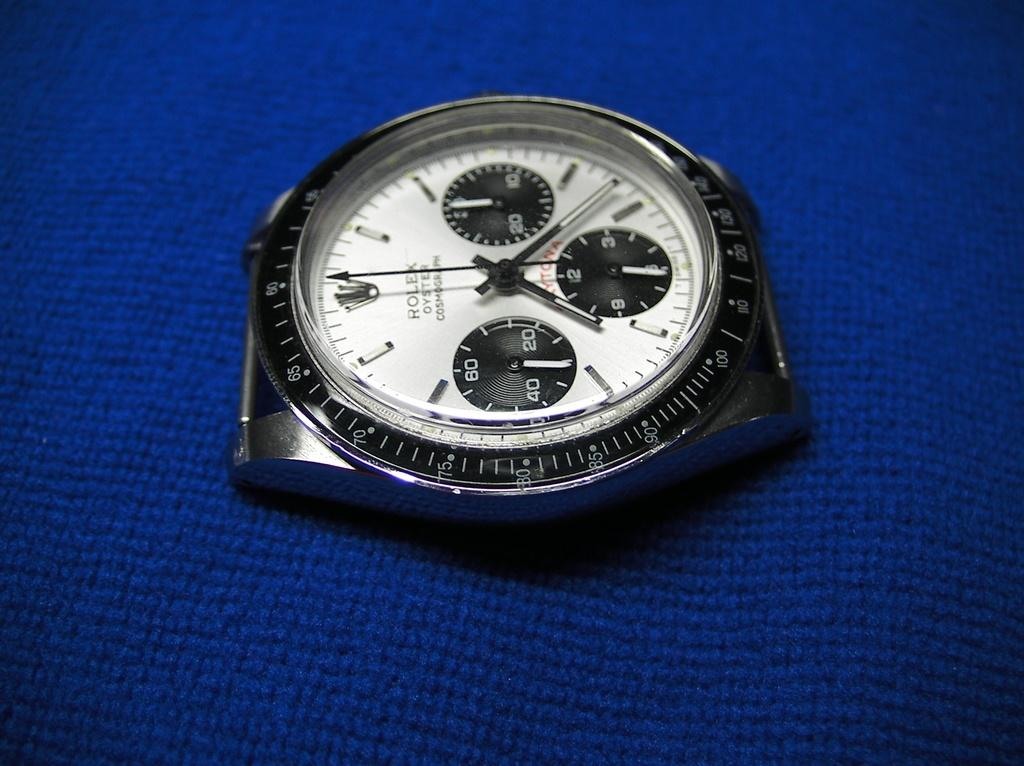<image>
Give a short and clear explanation of the subsequent image. A Rolex watch on a blue surface has a white face. 